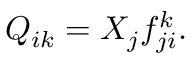Convert formula to latex. <formula><loc_0><loc_0><loc_500><loc_500>Q _ { i k } = X _ { j } f _ { j i } ^ { k } .</formula> 